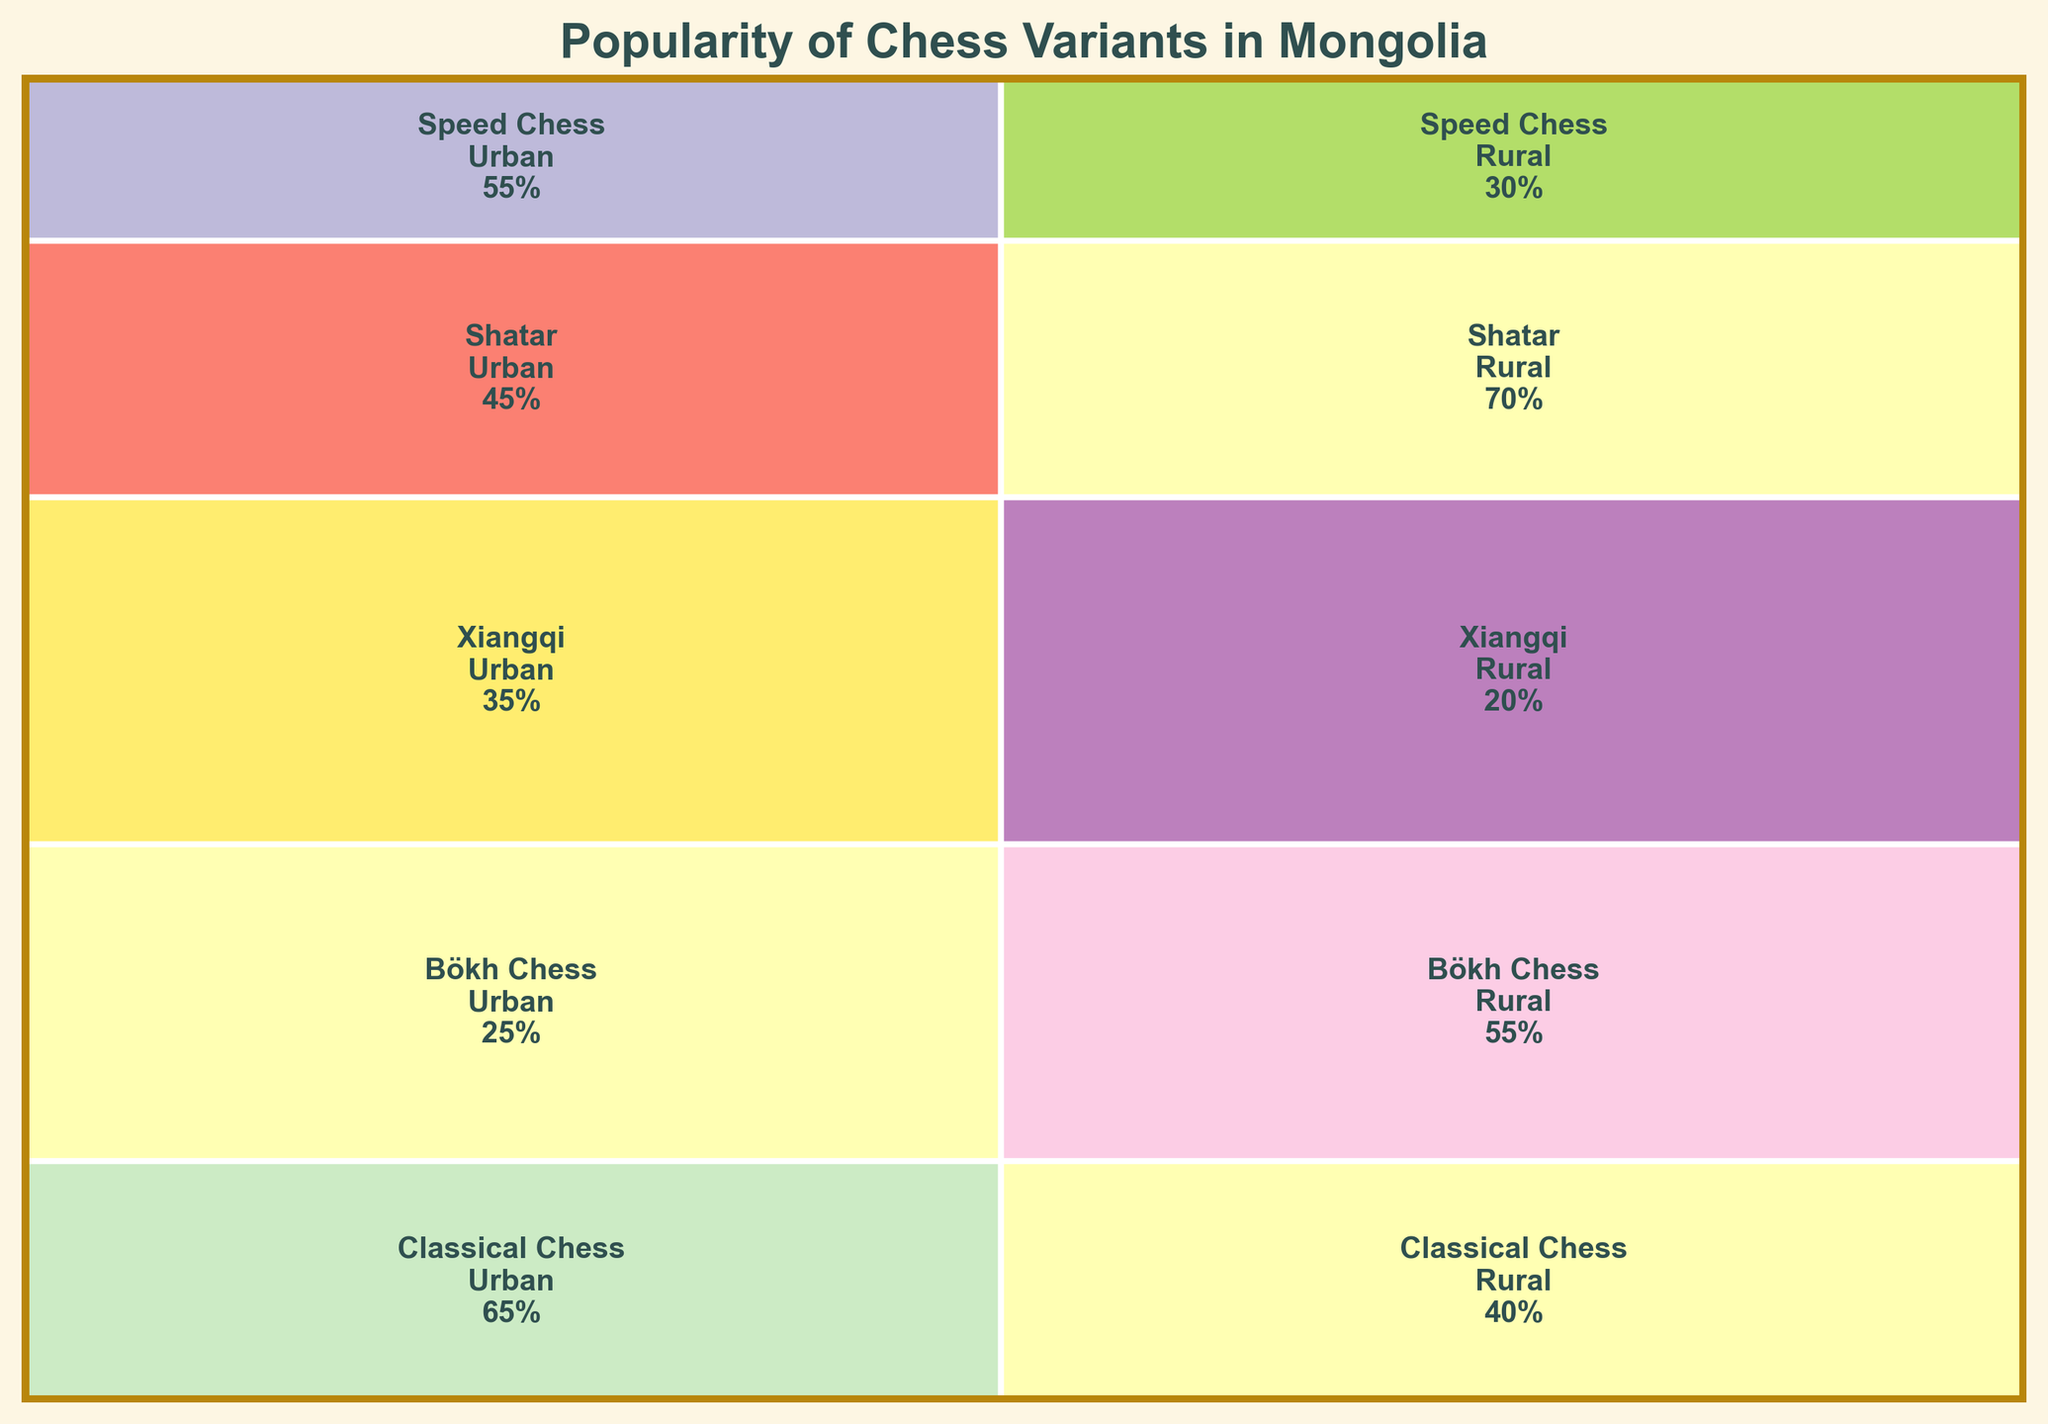What is the title of the plot? The title is located at the top of the plot, which typically summarizes the data represented in the figure. Here, the title explains the subject of the plot.
Answer: Popularity of Chess Variants in Mongolia Which chess variant has the highest popularity in rural areas? Look at the segment dimensions and values for rural areas. The largest rectangle in the rural section indicates the variant with the highest popularity there.
Answer: Shatar What is the least popular chess variant in urban areas? Compare the sizes and values within the segments for urban areas to identify the smallest one, which indicates the variant with the lowest popularity.
Answer: Bökh Chess How many percentage points more popular is Classical Chess in urban areas compared to Bökh Chess in urban areas? Subtract the popularity percentage of Bökh Chess from that of Classical Chess in the urban segment. The plot shows Classical Chess with 65% and Bökh Chess with 25%.
Answer: 40 What is the combined popularity of Shatar in both urban and rural areas? Add the popularity percentages of Shatar in urban and rural areas as shown on the plot. Shatar has 45% in urban and 70% in rural areas.
Answer: 115 How does the popularity of Classical Chess in urban areas compare to Xiangqi in the same area? Compare the popularity percentages of both chess variants in the urban segment. Classical Chess has 65% while Xiangqi has 35%.
Answer: Classical Chess is more popular Which area type shows a higher overall popularity for Bökh Chess? Compare the values for Bökh Chess in urban and rural areas. Bökh Chess has 25% in urban and 55% in rural areas.
Answer: Rural What is the total popularity percentage of all chess variants in rural areas? Sum the popularity percentages for all variants in the rural column of the plot (40 + 55 + 20 + 70 + 30).
Answer: 215% Is Xiangqi more popular in urban or rural areas? Compare the respective sizes and values in the urban and rural segments for Xiangqi. Xiangqi has 35% in urban and 20% in rural areas.
Answer: Urban Which chess variant has the smallest combined popularity in both urban and rural areas? Calculate the sum of popularity percentages for each variant across both areas and identify the smallest sum. Xiangqi has (35% + 20%) = 55%, which is the smallest.
Answer: Xiangqi 